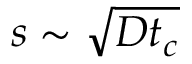<formula> <loc_0><loc_0><loc_500><loc_500>s \sim \sqrt { D t _ { c } }</formula> 